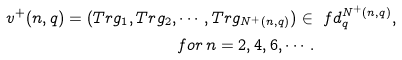Convert formula to latex. <formula><loc_0><loc_0><loc_500><loc_500>v ^ { + } ( n , q ) = ( T r g _ { 1 } , T r g _ { 2 } , & \cdots , T r g _ { N ^ { + } ( n , q ) } ) \in \ f d _ { q } ^ { N ^ { + } ( n , q ) } , \\ & f o r \, n = 2 , 4 , 6 , \cdots .</formula> 